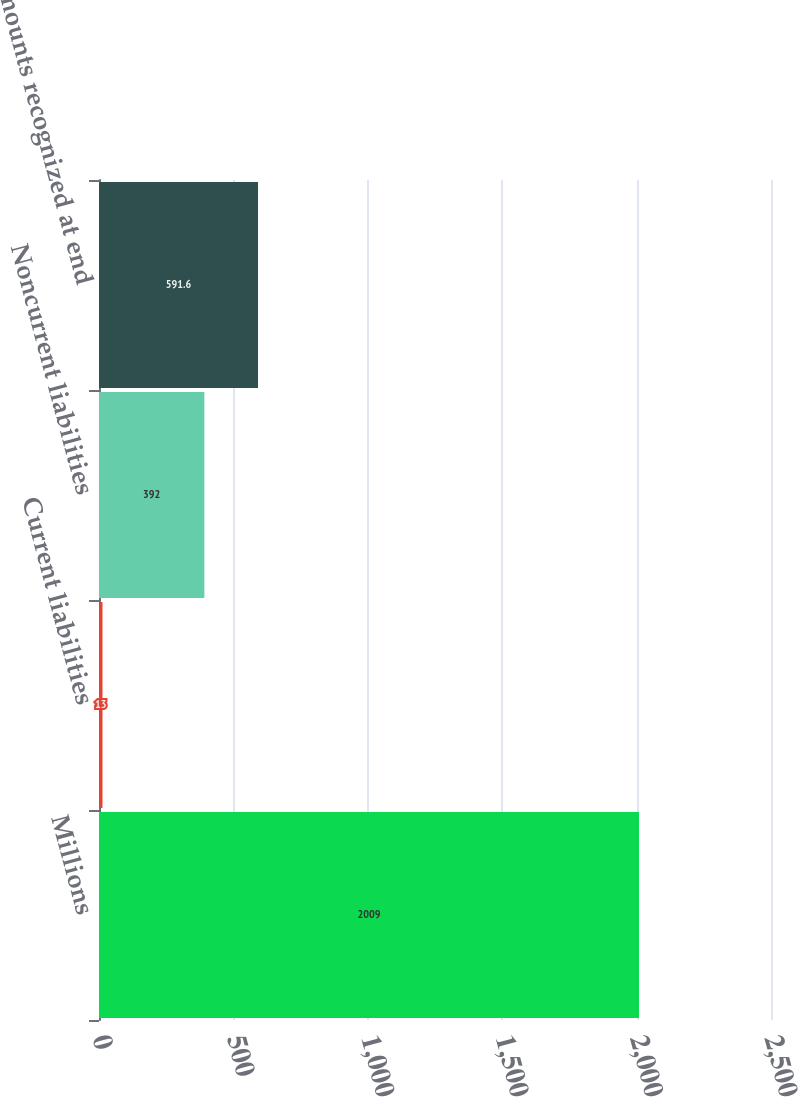Convert chart to OTSL. <chart><loc_0><loc_0><loc_500><loc_500><bar_chart><fcel>Millions<fcel>Current liabilities<fcel>Noncurrent liabilities<fcel>Net amounts recognized at end<nl><fcel>2009<fcel>13<fcel>392<fcel>591.6<nl></chart> 